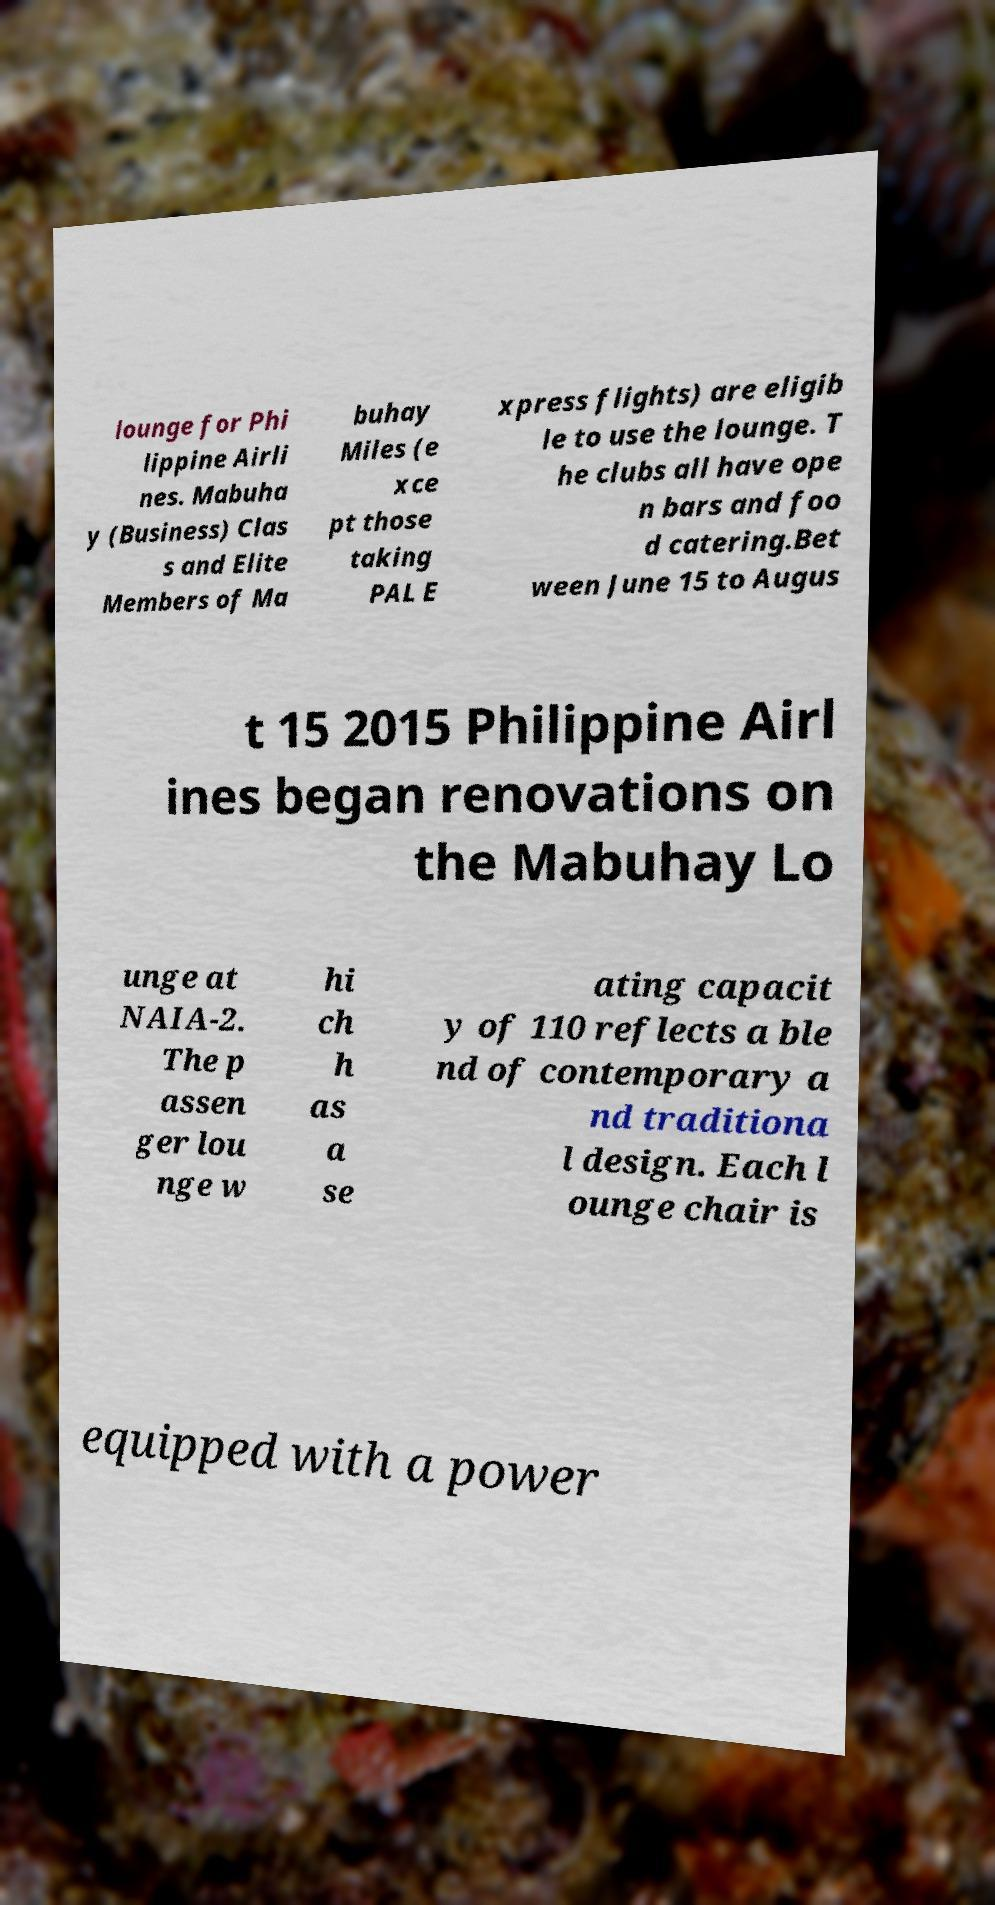Could you extract and type out the text from this image? lounge for Phi lippine Airli nes. Mabuha y (Business) Clas s and Elite Members of Ma buhay Miles (e xce pt those taking PAL E xpress flights) are eligib le to use the lounge. T he clubs all have ope n bars and foo d catering.Bet ween June 15 to Augus t 15 2015 Philippine Airl ines began renovations on the Mabuhay Lo unge at NAIA-2. The p assen ger lou nge w hi ch h as a se ating capacit y of 110 reflects a ble nd of contemporary a nd traditiona l design. Each l ounge chair is equipped with a power 